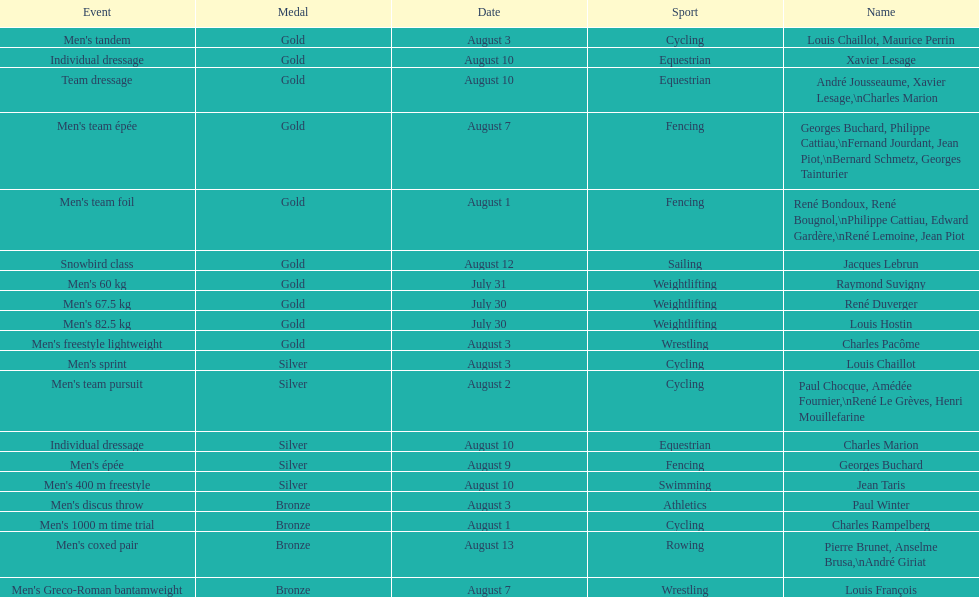How many total gold medals were won by weightlifting? 3. 